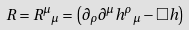Convert formula to latex. <formula><loc_0><loc_0><loc_500><loc_500>R = { R ^ { \mu } } _ { \mu } = \left ( \partial _ { \rho } \partial ^ { \mu } { h ^ { \rho } } _ { \mu } - \Box h \right )</formula> 